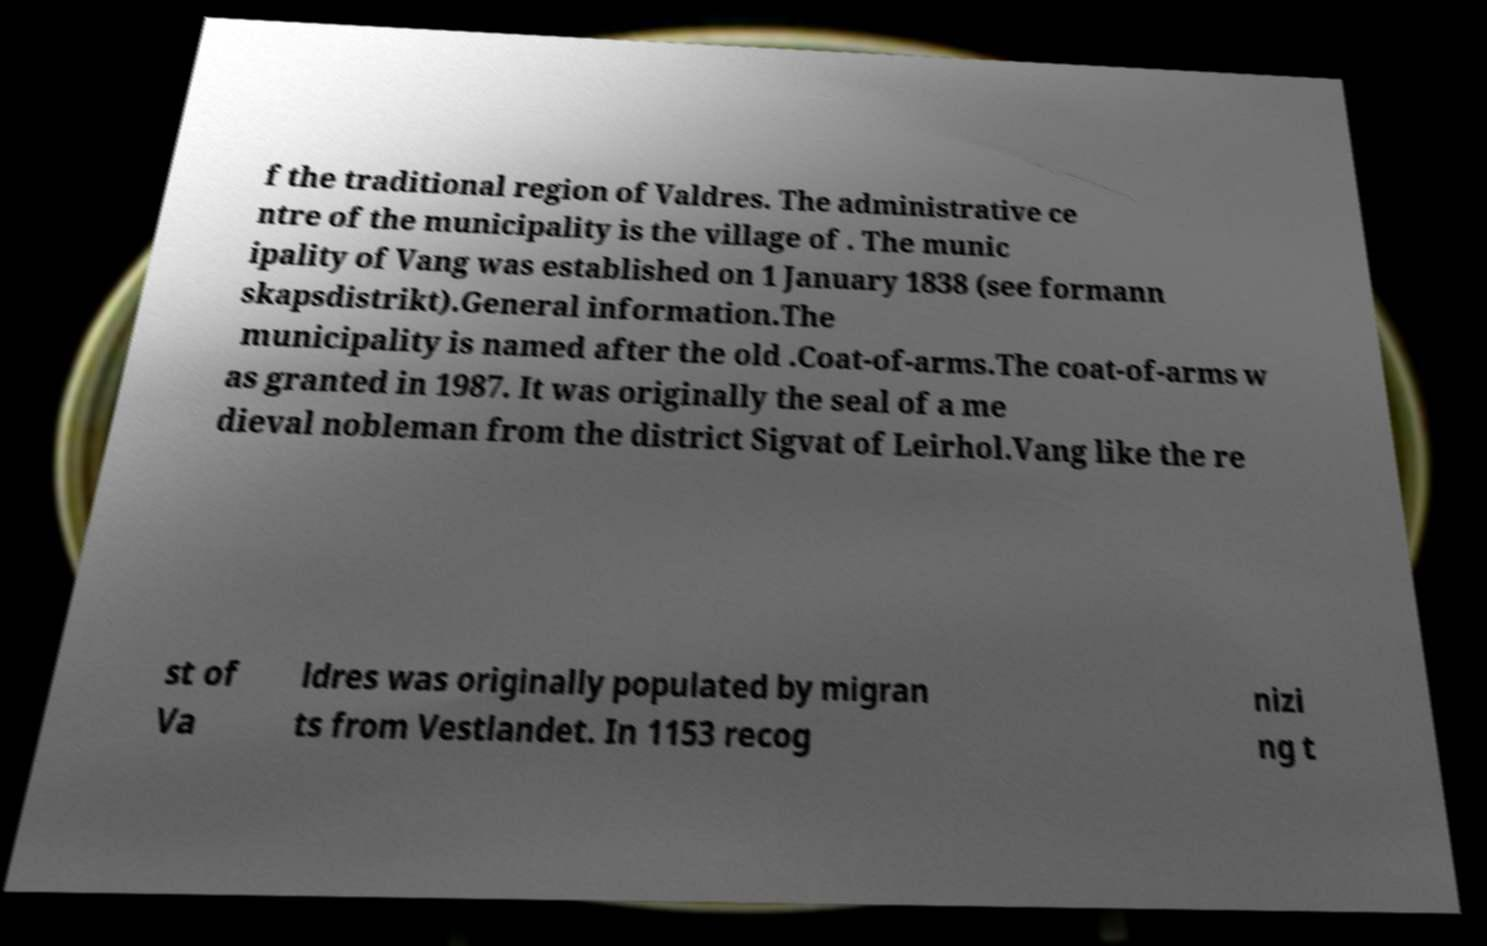Please identify and transcribe the text found in this image. f the traditional region of Valdres. The administrative ce ntre of the municipality is the village of . The munic ipality of Vang was established on 1 January 1838 (see formann skapsdistrikt).General information.The municipality is named after the old .Coat-of-arms.The coat-of-arms w as granted in 1987. It was originally the seal of a me dieval nobleman from the district Sigvat of Leirhol.Vang like the re st of Va ldres was originally populated by migran ts from Vestlandet. In 1153 recog nizi ng t 